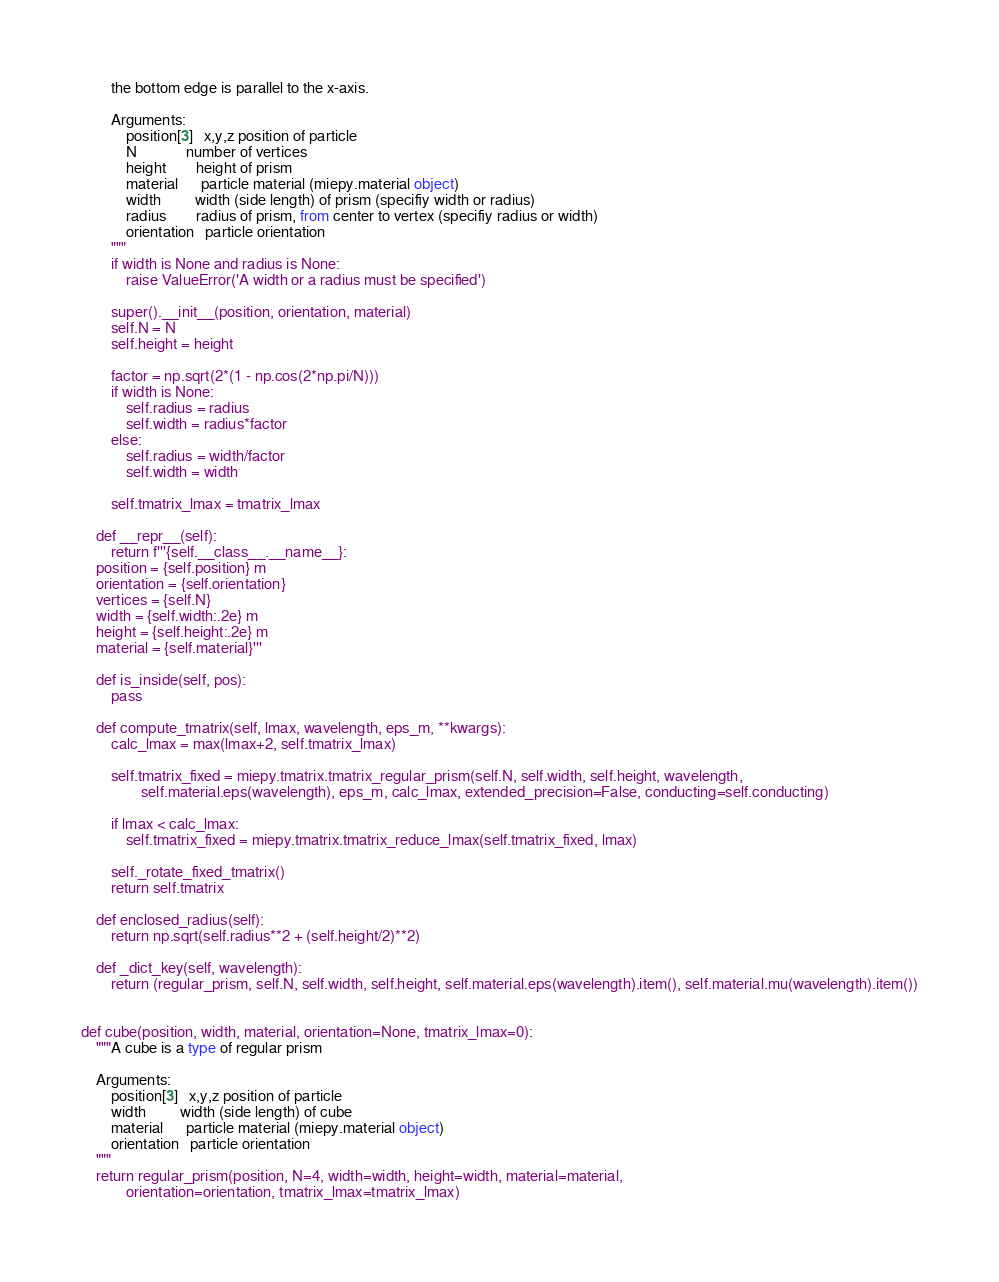Convert code to text. <code><loc_0><loc_0><loc_500><loc_500><_Python_>        the bottom edge is parallel to the x-axis.

        Arguments:
            position[3]   x,y,z position of particle
            N             number of vertices
            height        height of prism
            material      particle material (miepy.material object)
            width         width (side length) of prism (specifiy width or radius)
            radius        radius of prism, from center to vertex (specifiy radius or width)
            orientation   particle orientation
        """
        if width is None and radius is None:
            raise ValueError('A width or a radius must be specified')

        super().__init__(position, orientation, material)
        self.N = N
        self.height = height

        factor = np.sqrt(2*(1 - np.cos(2*np.pi/N)))
        if width is None:
            self.radius = radius
            self.width = radius*factor
        else:
            self.radius = width/factor
            self.width = width

        self.tmatrix_lmax = tmatrix_lmax

    def __repr__(self):
        return f'''{self.__class__.__name__}:
    position = {self.position} m
    orientation = {self.orientation}
    vertices = {self.N}
    width = {self.width:.2e} m
    height = {self.height:.2e} m
    material = {self.material}'''

    def is_inside(self, pos):
        pass

    def compute_tmatrix(self, lmax, wavelength, eps_m, **kwargs):
        calc_lmax = max(lmax+2, self.tmatrix_lmax)

        self.tmatrix_fixed = miepy.tmatrix.tmatrix_regular_prism(self.N, self.width, self.height, wavelength, 
                self.material.eps(wavelength), eps_m, calc_lmax, extended_precision=False, conducting=self.conducting)

        if lmax < calc_lmax:
            self.tmatrix_fixed = miepy.tmatrix.tmatrix_reduce_lmax(self.tmatrix_fixed, lmax)

        self._rotate_fixed_tmatrix()
        return self.tmatrix

    def enclosed_radius(self):
        return np.sqrt(self.radius**2 + (self.height/2)**2)

    def _dict_key(self, wavelength):
        return (regular_prism, self.N, self.width, self.height, self.material.eps(wavelength).item(), self.material.mu(wavelength).item())


def cube(position, width, material, orientation=None, tmatrix_lmax=0):
    """A cube is a type of regular prism

    Arguments:
        position[3]   x,y,z position of particle
        width         width (side length) of cube
        material      particle material (miepy.material object)
        orientation   particle orientation
    """
    return regular_prism(position, N=4, width=width, height=width, material=material,
            orientation=orientation, tmatrix_lmax=tmatrix_lmax)
</code> 